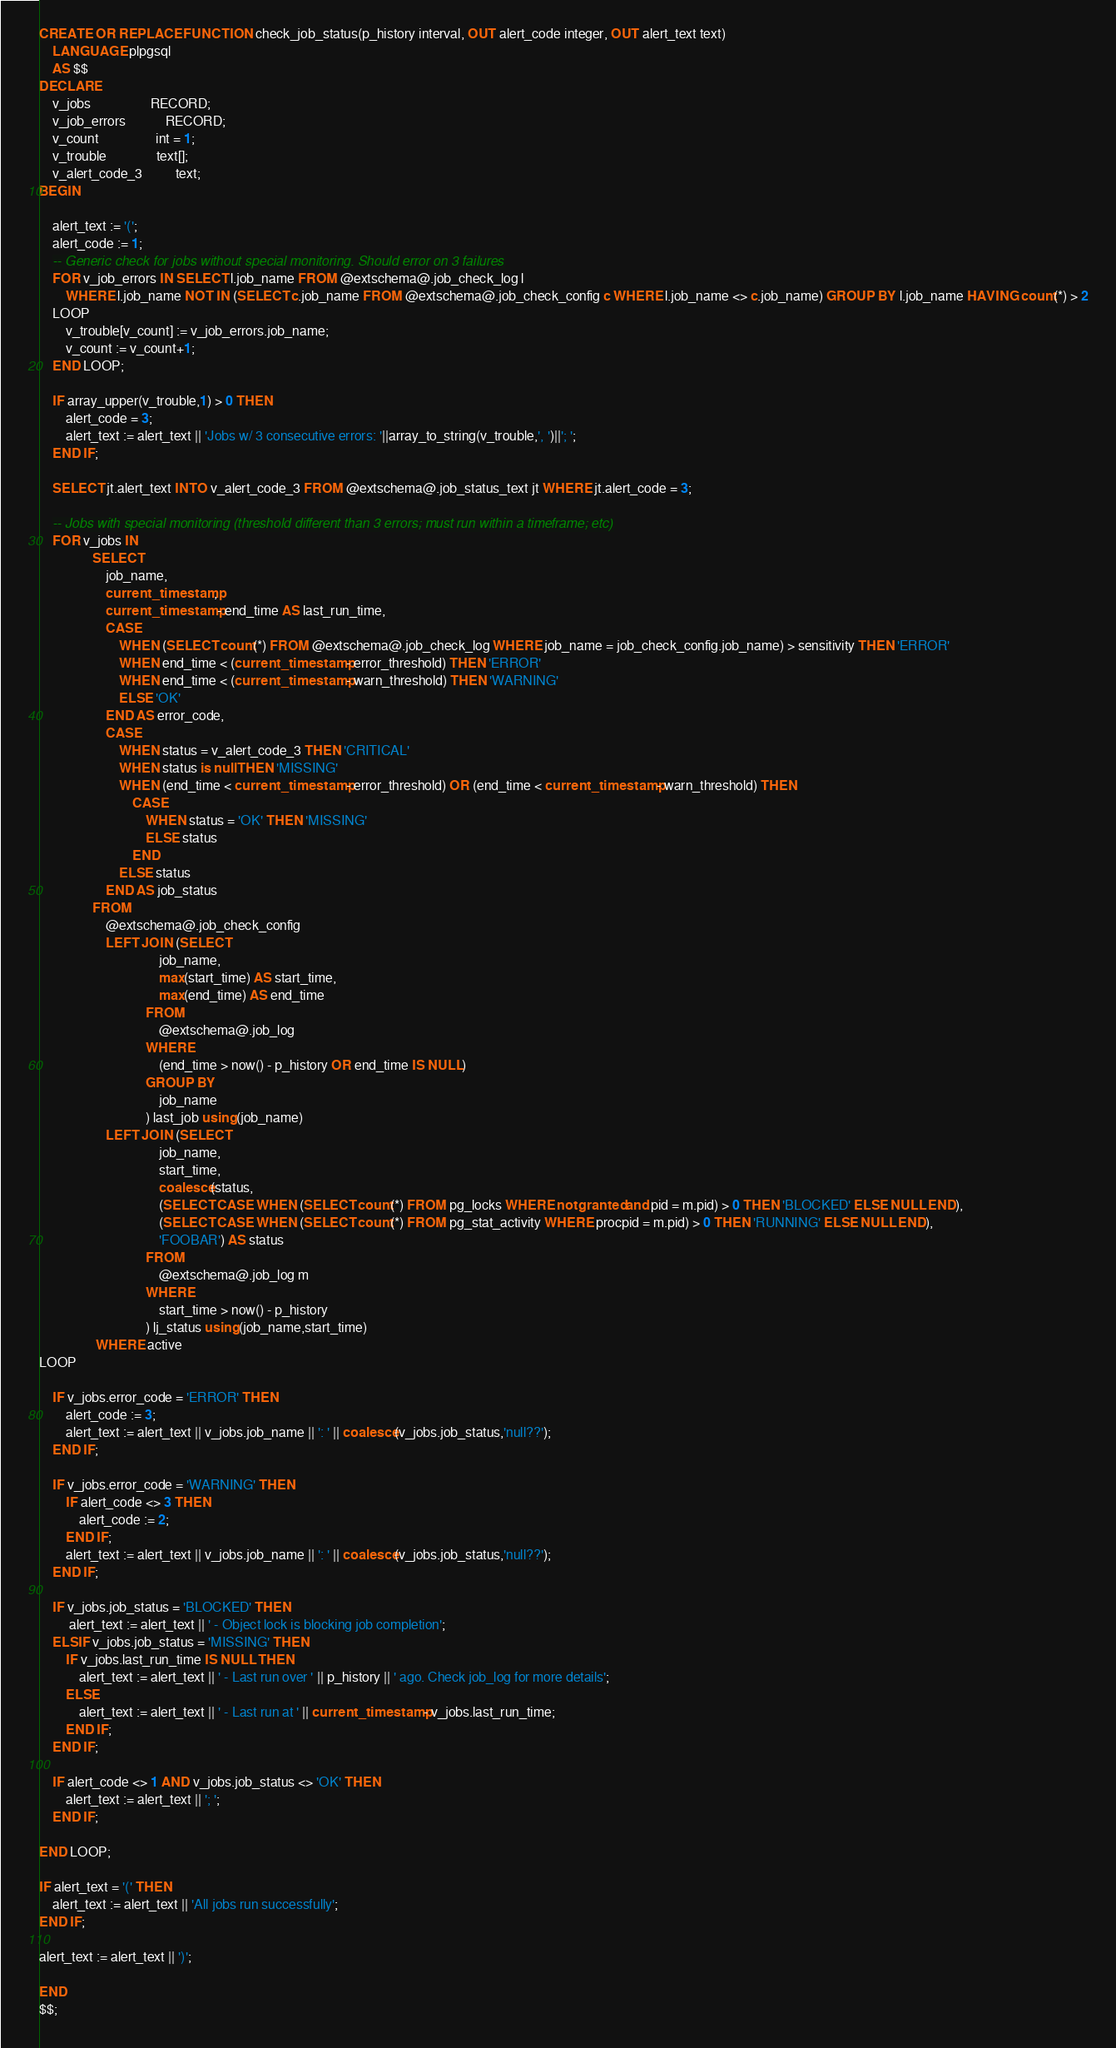<code> <loc_0><loc_0><loc_500><loc_500><_SQL_>CREATE OR REPLACE FUNCTION check_job_status(p_history interval, OUT alert_code integer, OUT alert_text text) 
    LANGUAGE plpgsql
    AS $$
DECLARE
    v_jobs                  RECORD;
    v_job_errors            RECORD;
    v_count                 int = 1;
    v_trouble               text[];
    v_alert_code_3          text;
BEGIN
    
    alert_text := '(';
    alert_code := 1;
    -- Generic check for jobs without special monitoring. Should error on 3 failures
    FOR v_job_errors IN SELECT l.job_name FROM @extschema@.job_check_log l 
        WHERE l.job_name NOT IN (SELECT c.job_name FROM @extschema@.job_check_config c WHERE l.job_name <> c.job_name) GROUP BY l.job_name HAVING count(*) > 2
    LOOP
        v_trouble[v_count] := v_job_errors.job_name;
        v_count := v_count+1;
    END LOOP;
    
    IF array_upper(v_trouble,1) > 0 THEN
        alert_code = 3;
        alert_text := alert_text || 'Jobs w/ 3 consecutive errors: '||array_to_string(v_trouble,', ')||'; ';
    END IF;

    SELECT jt.alert_text INTO v_alert_code_3 FROM @extschema@.job_status_text jt WHERE jt.alert_code = 3;
    
    -- Jobs with special monitoring (threshold different than 3 errors; must run within a timeframe; etc)
    FOR v_jobs IN 
                SELECT
                    job_name,
                    current_timestamp,
                    current_timestamp - end_time AS last_run_time,  
                    CASE
                        WHEN (SELECT count(*) FROM @extschema@.job_check_log WHERE job_name = job_check_config.job_name) > sensitivity THEN 'ERROR'  
                        WHEN end_time < (current_timestamp - error_threshold) THEN 'ERROR' 
                        WHEN end_time < (current_timestamp - warn_threshold) THEN 'WARNING'
                        ELSE 'OK'
                    END AS error_code,
                    CASE
                        WHEN status = v_alert_code_3 THEN 'CRITICAL'
                        WHEN status is null THEN 'MISSING' 
                        WHEN (end_time < current_timestamp - error_threshold) OR (end_time < current_timestamp - warn_threshold) THEN 
                            CASE 
                                WHEN status = 'OK' THEN 'MISSING'
                                ELSE status
                            END
                        ELSE status
                    END AS job_status
                FROM
                    @extschema@.job_check_config 
                    LEFT JOIN (SELECT
                                    job_name,
                                    max(start_time) AS start_time,
                                    max(end_time) AS end_time 
                                FROM
                                    @extschema@.job_log
                                WHERE
                                    (end_time > now() - p_history OR end_time IS NULL)
                                GROUP BY 
                                    job_name 
                                ) last_job using (job_name)
                    LEFT JOIN (SELECT 
                                    job_name,    
                                    start_time, 
                                    coalesce(status,
                                    (SELECT CASE WHEN (SELECT count(*) FROM pg_locks WHERE not granted and pid = m.pid) > 0 THEN 'BLOCKED' ELSE NULL END),
                                    (SELECT CASE WHEN (SELECT count(*) FROM pg_stat_activity WHERE procpid = m.pid) > 0 THEN 'RUNNING' ELSE NULL END),
                                    'FOOBAR') AS status
                                FROM
                                    @extschema@.job_log m 
                                WHERE 
                                    start_time > now() - p_history
                                ) lj_status using (job_name,start_time)   
                 WHERE active      
LOOP

    IF v_jobs.error_code = 'ERROR' THEN
        alert_code := 3;
        alert_text := alert_text || v_jobs.job_name || ': ' || coalesce(v_jobs.job_status,'null??');
    END IF;

    IF v_jobs.error_code = 'WARNING' THEN
        IF alert_code <> 3 THEN
            alert_code := 2;
        END IF;
        alert_text := alert_text || v_jobs.job_name || ': ' || coalesce(v_jobs.job_status,'null??');
    END IF;
    
    IF v_jobs.job_status = 'BLOCKED' THEN
         alert_text := alert_text || ' - Object lock is blocking job completion';
    ELSIF v_jobs.job_status = 'MISSING' THEN
        IF v_jobs.last_run_time IS NULL THEN  
            alert_text := alert_text || ' - Last run over ' || p_history || ' ago. Check job_log for more details';
        ELSE
            alert_text := alert_text || ' - Last run at ' || current_timestamp - v_jobs.last_run_time;
        END IF;
    END IF;

    IF alert_code <> 1 AND v_jobs.job_status <> 'OK' THEN
        alert_text := alert_text || '; ';
    END IF;

END LOOP;

IF alert_text = '(' THEN
    alert_text := alert_text || 'All jobs run successfully';
END IF;

alert_text := alert_text || ')';

END
$$;
</code> 